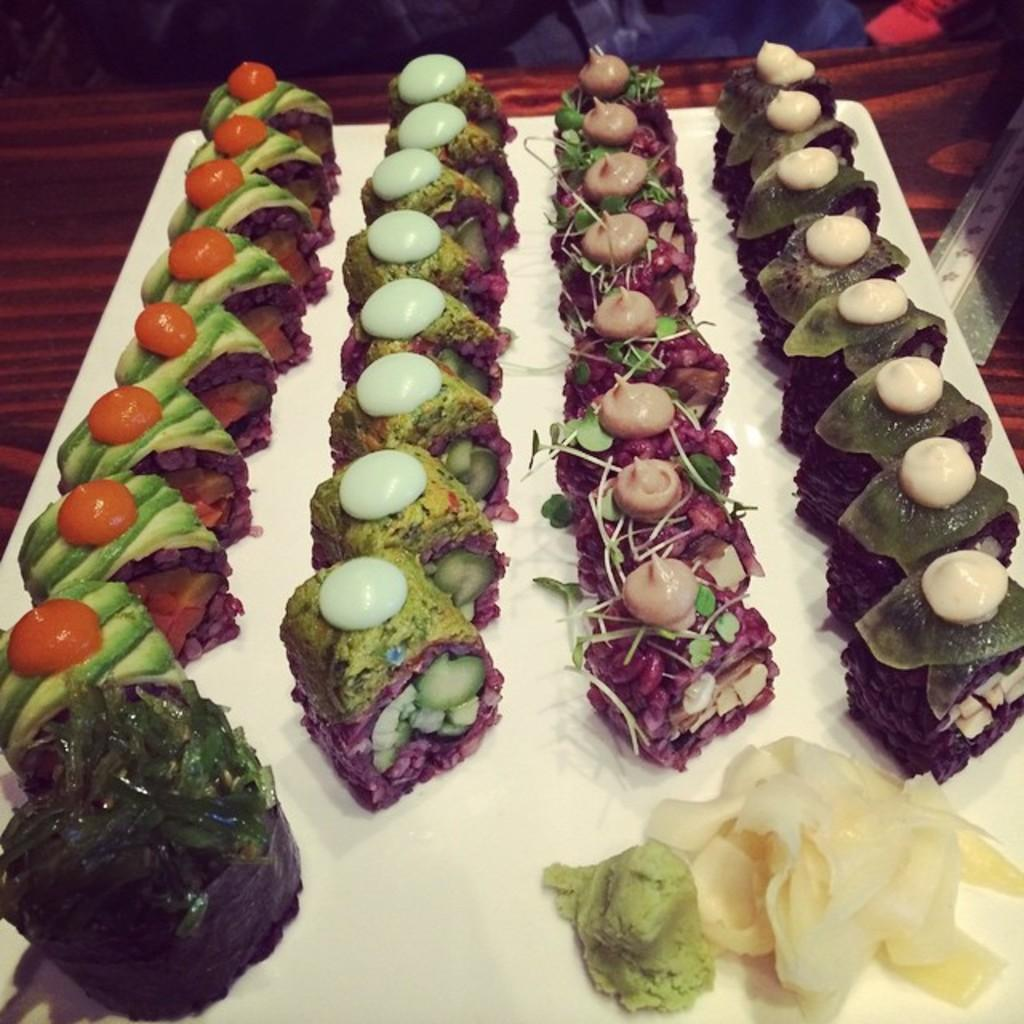What is on the plate in the image? There are food items on a plate in the image. Can you describe the object in the image? Unfortunately, there is not enough information provided to describe the object in the image. What can be seen in the background of the image? There are items visible in the background of the image, but their specific nature is not mentioned in the provided facts. What type of stocking is hanging from the ceiling in the image? There is no stocking present in the image. What kind of plants are growing in the background of the image? There is no information provided about plants in the image. 